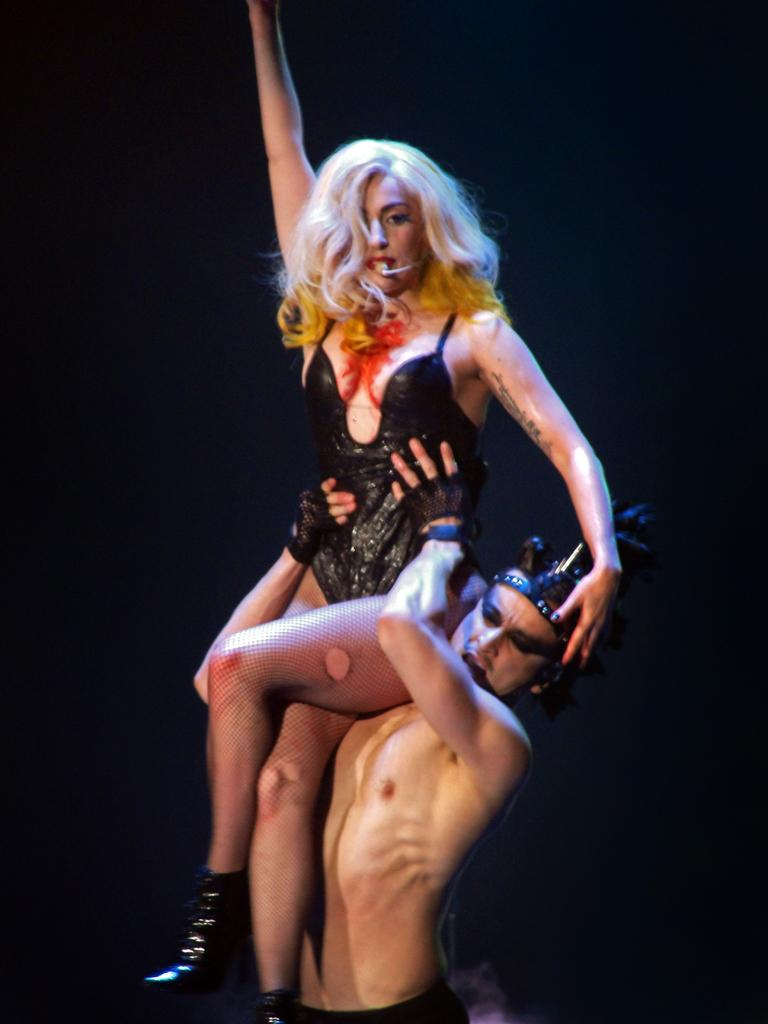What is the man in the image doing? The man is standing and holding a woman. What is the woman in the image wearing? The woman is wearing a black dress. What position is the woman in relation to the man? The woman is sitting on the man's shoulder. How would you describe the background of the image? The background of the image is dark in color. What year does the image depict? The image does not provide any information about the year it depicts. Can you see the ocean in the background of the image? No, the background of the image is dark, and there is no indication of an ocean or any other body of water. 